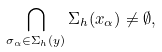<formula> <loc_0><loc_0><loc_500><loc_500>\bigcap _ { \sigma _ { \alpha } \in \Sigma _ { h } ( y ) } \Sigma _ { h } ( x _ { \alpha } ) \neq \emptyset ,</formula> 